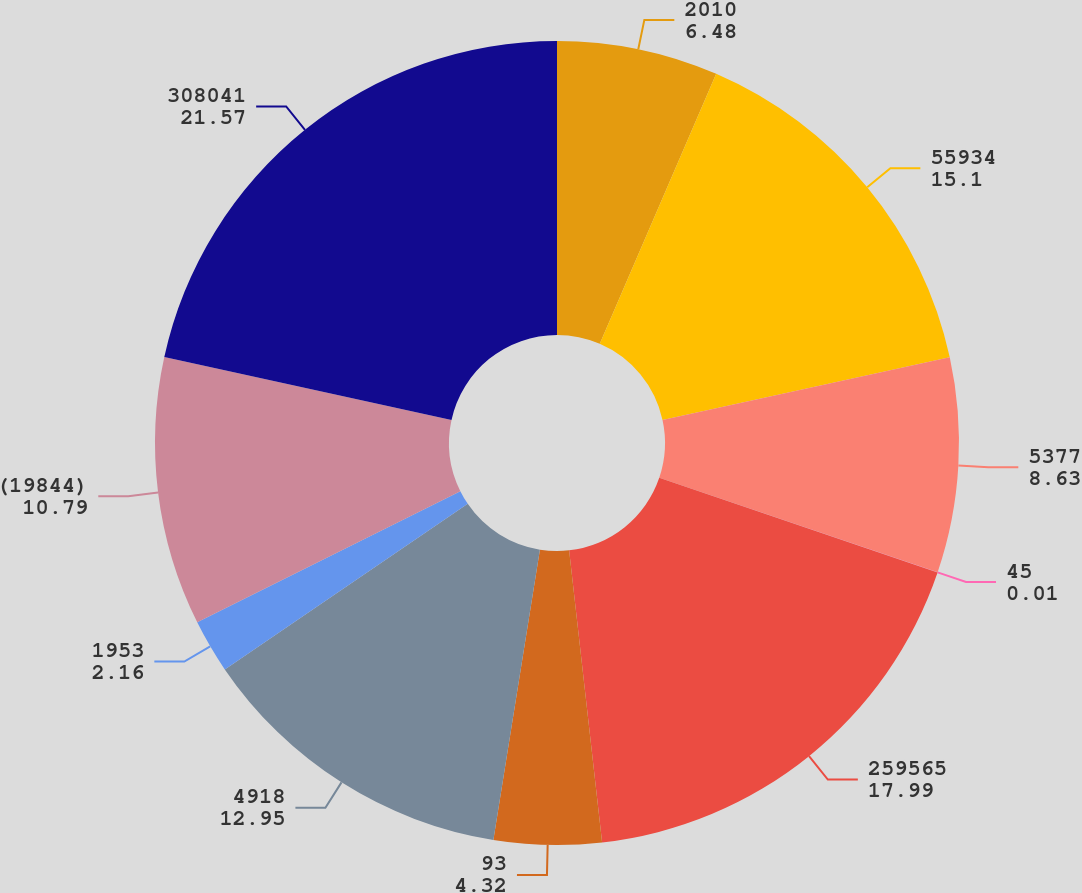Convert chart. <chart><loc_0><loc_0><loc_500><loc_500><pie_chart><fcel>2010<fcel>55934<fcel>5377<fcel>45<fcel>259565<fcel>93<fcel>4918<fcel>1953<fcel>(19844)<fcel>308041<nl><fcel>6.48%<fcel>15.1%<fcel>8.63%<fcel>0.01%<fcel>17.99%<fcel>4.32%<fcel>12.95%<fcel>2.16%<fcel>10.79%<fcel>21.57%<nl></chart> 